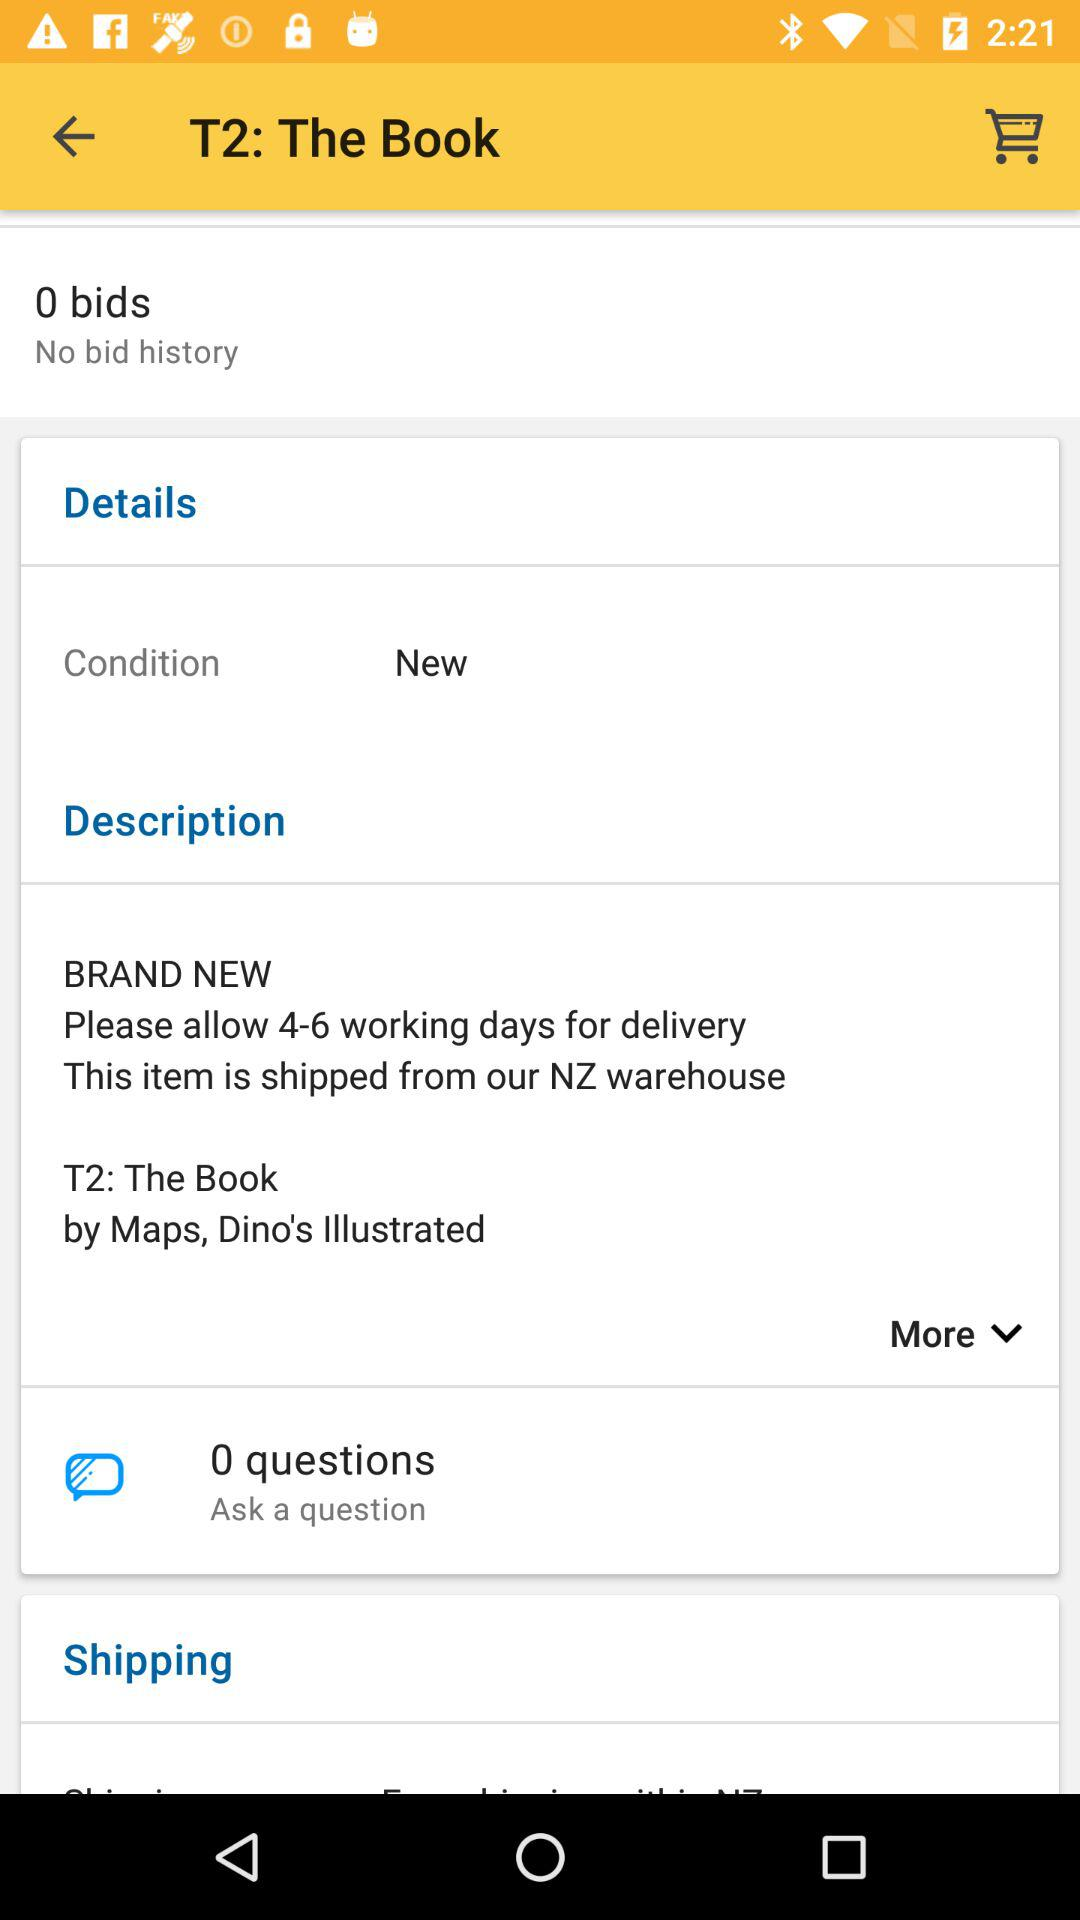How many bids are shown on the screen? There are 0 bids shown on the screen. 